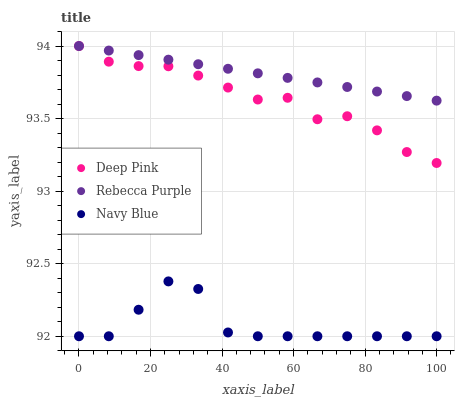Does Navy Blue have the minimum area under the curve?
Answer yes or no. Yes. Does Rebecca Purple have the maximum area under the curve?
Answer yes or no. Yes. Does Deep Pink have the minimum area under the curve?
Answer yes or no. No. Does Deep Pink have the maximum area under the curve?
Answer yes or no. No. Is Rebecca Purple the smoothest?
Answer yes or no. Yes. Is Navy Blue the roughest?
Answer yes or no. Yes. Is Deep Pink the smoothest?
Answer yes or no. No. Is Deep Pink the roughest?
Answer yes or no. No. Does Navy Blue have the lowest value?
Answer yes or no. Yes. Does Deep Pink have the lowest value?
Answer yes or no. No. Does Rebecca Purple have the highest value?
Answer yes or no. Yes. Is Navy Blue less than Deep Pink?
Answer yes or no. Yes. Is Rebecca Purple greater than Navy Blue?
Answer yes or no. Yes. Does Rebecca Purple intersect Deep Pink?
Answer yes or no. Yes. Is Rebecca Purple less than Deep Pink?
Answer yes or no. No. Is Rebecca Purple greater than Deep Pink?
Answer yes or no. No. Does Navy Blue intersect Deep Pink?
Answer yes or no. No. 